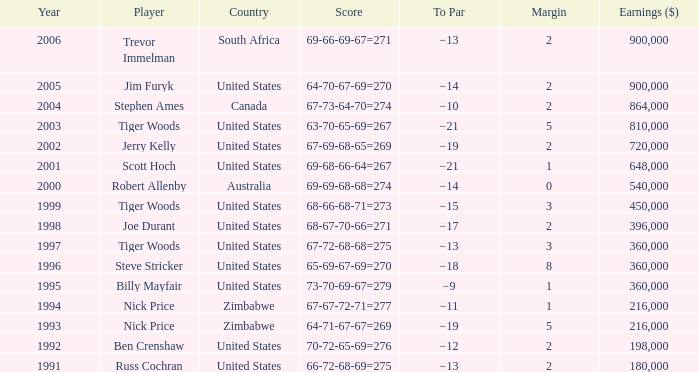What is the margin of canada? 2.0. 